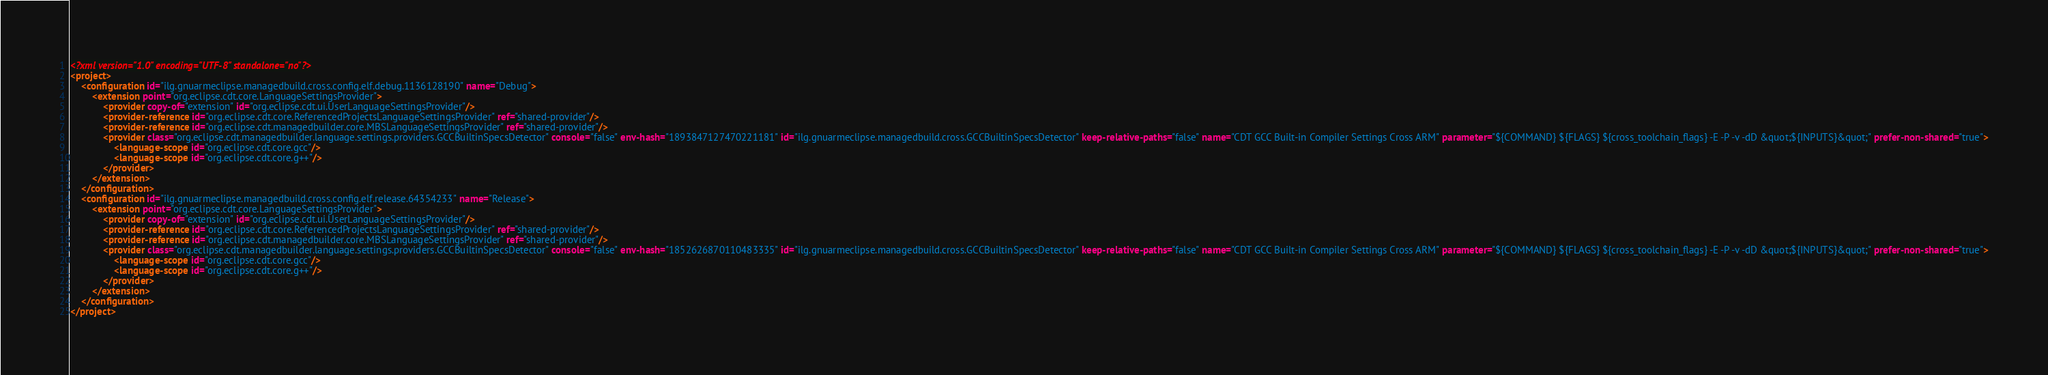Convert code to text. <code><loc_0><loc_0><loc_500><loc_500><_XML_><?xml version="1.0" encoding="UTF-8" standalone="no"?>
<project>
	<configuration id="ilg.gnuarmeclipse.managedbuild.cross.config.elf.debug.1136128190" name="Debug">
		<extension point="org.eclipse.cdt.core.LanguageSettingsProvider">
			<provider copy-of="extension" id="org.eclipse.cdt.ui.UserLanguageSettingsProvider"/>
			<provider-reference id="org.eclipse.cdt.core.ReferencedProjectsLanguageSettingsProvider" ref="shared-provider"/>
			<provider-reference id="org.eclipse.cdt.managedbuilder.core.MBSLanguageSettingsProvider" ref="shared-provider"/>
			<provider class="org.eclipse.cdt.managedbuilder.language.settings.providers.GCCBuiltinSpecsDetector" console="false" env-hash="1893847127470221181" id="ilg.gnuarmeclipse.managedbuild.cross.GCCBuiltinSpecsDetector" keep-relative-paths="false" name="CDT GCC Built-in Compiler Settings Cross ARM" parameter="${COMMAND} ${FLAGS} ${cross_toolchain_flags} -E -P -v -dD &quot;${INPUTS}&quot;" prefer-non-shared="true">
				<language-scope id="org.eclipse.cdt.core.gcc"/>
				<language-scope id="org.eclipse.cdt.core.g++"/>
			</provider>
		</extension>
	</configuration>
	<configuration id="ilg.gnuarmeclipse.managedbuild.cross.config.elf.release.64354233" name="Release">
		<extension point="org.eclipse.cdt.core.LanguageSettingsProvider">
			<provider copy-of="extension" id="org.eclipse.cdt.ui.UserLanguageSettingsProvider"/>
			<provider-reference id="org.eclipse.cdt.core.ReferencedProjectsLanguageSettingsProvider" ref="shared-provider"/>
			<provider-reference id="org.eclipse.cdt.managedbuilder.core.MBSLanguageSettingsProvider" ref="shared-provider"/>
			<provider class="org.eclipse.cdt.managedbuilder.language.settings.providers.GCCBuiltinSpecsDetector" console="false" env-hash="1852626870110483335" id="ilg.gnuarmeclipse.managedbuild.cross.GCCBuiltinSpecsDetector" keep-relative-paths="false" name="CDT GCC Built-in Compiler Settings Cross ARM" parameter="${COMMAND} ${FLAGS} ${cross_toolchain_flags} -E -P -v -dD &quot;${INPUTS}&quot;" prefer-non-shared="true">
				<language-scope id="org.eclipse.cdt.core.gcc"/>
				<language-scope id="org.eclipse.cdt.core.g++"/>
			</provider>
		</extension>
	</configuration>
</project>
</code> 